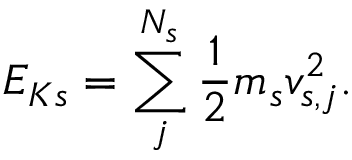<formula> <loc_0><loc_0><loc_500><loc_500>E _ { K s } = \sum _ { j } ^ { N _ { s } } \frac { 1 } { 2 } m _ { s } v _ { s , j } ^ { 2 } .</formula> 